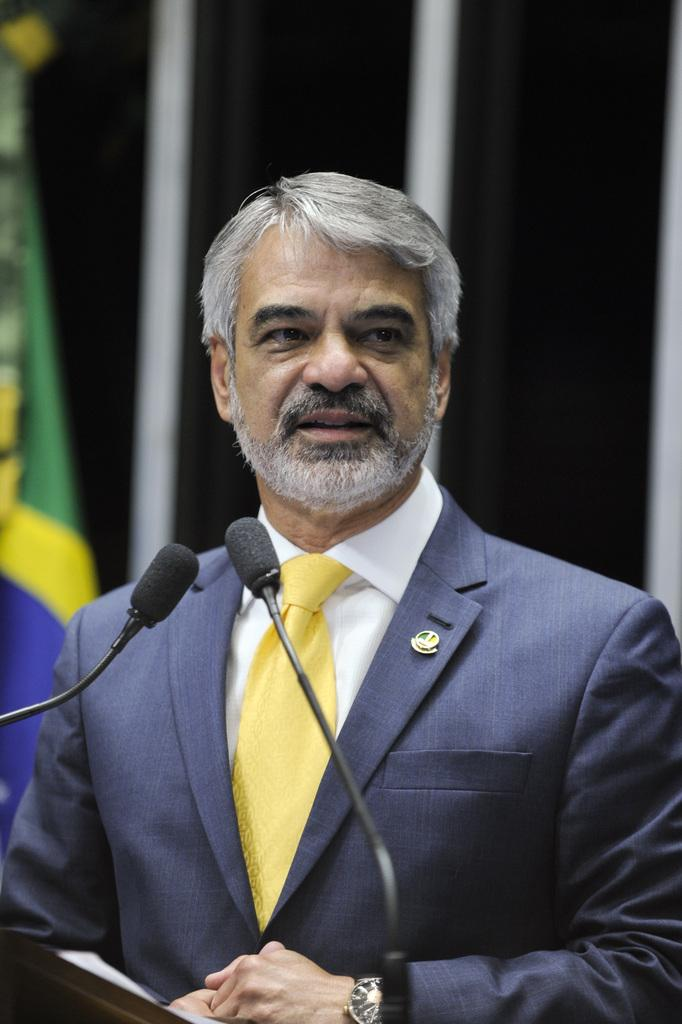Who is the main subject in the image? There is a man in the image. What is the man doing in the image? The man is standing in front of microphones. What is the man wearing in the image? The man is wearing a suit, a tie, a shirt, and a watch. What can be seen in the background of the image? There is a flag and a wall in the background of the image. What type of truck can be seen in the image? There is no truck present in the image. How many ears does the man have in the image? The image does not show the man's ears, so it cannot be determined from the image. 